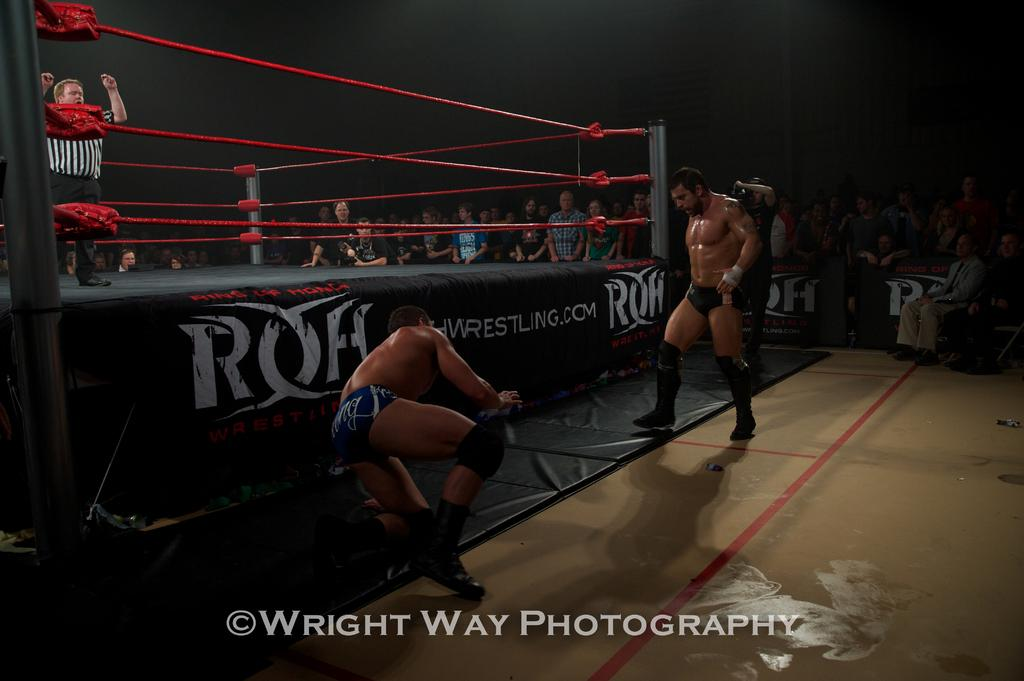<image>
Share a concise interpretation of the image provided. Two wrestlers in front a a ring for ROH wrestling. 